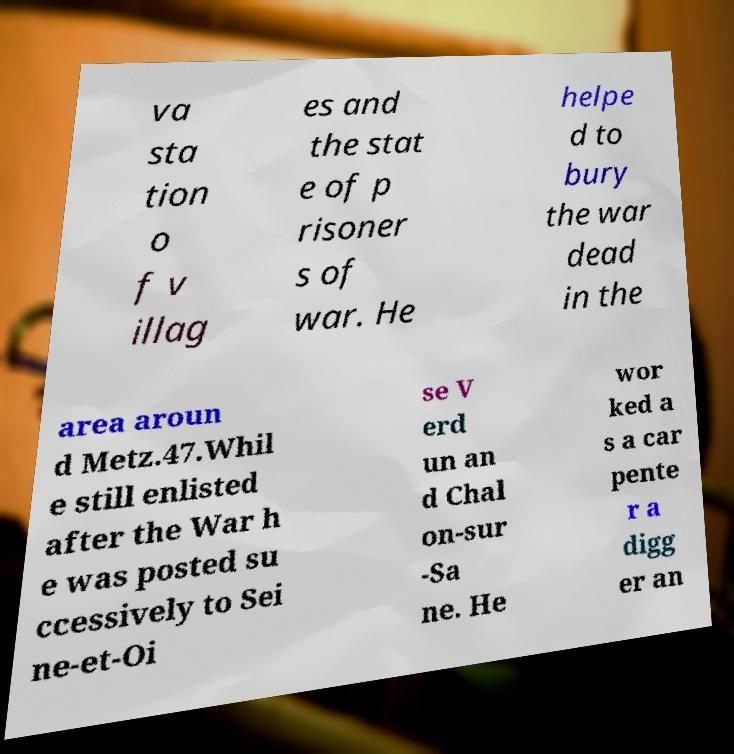Could you assist in decoding the text presented in this image and type it out clearly? va sta tion o f v illag es and the stat e of p risoner s of war. He helpe d to bury the war dead in the area aroun d Metz.47.Whil e still enlisted after the War h e was posted su ccessively to Sei ne-et-Oi se V erd un an d Chal on-sur -Sa ne. He wor ked a s a car pente r a digg er an 